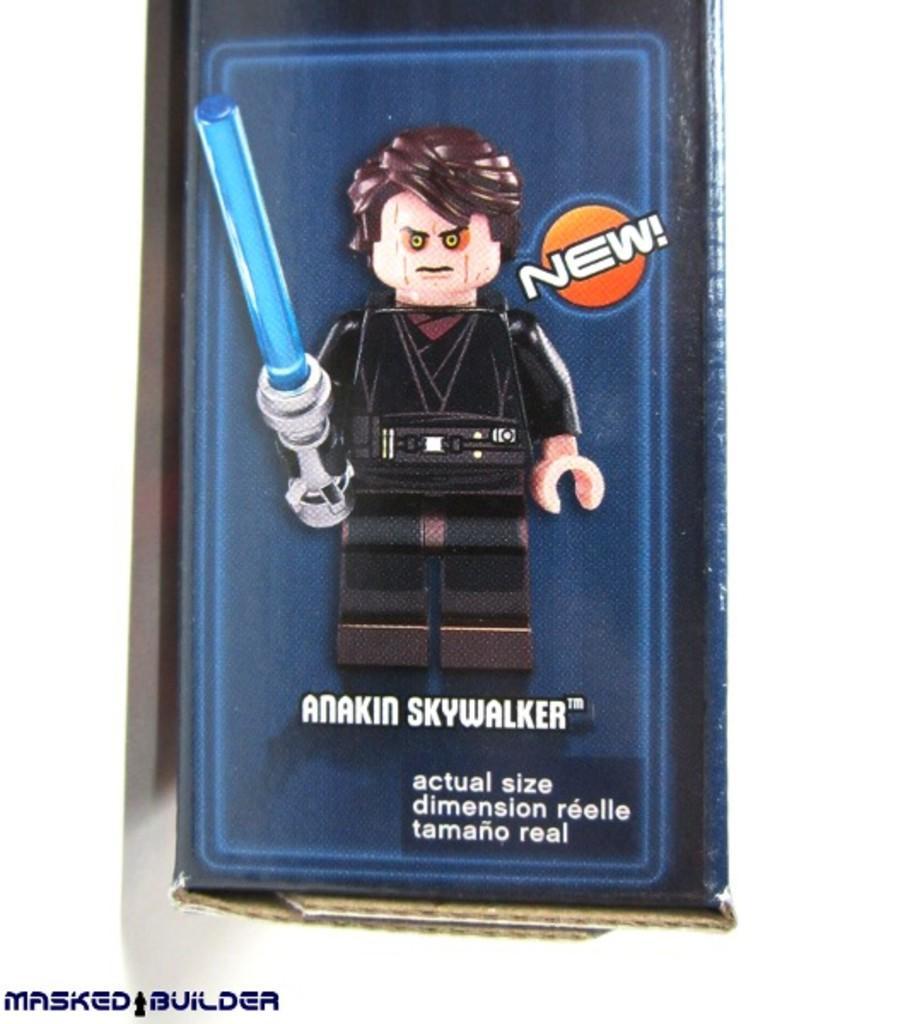Describe this image in one or two sentences. In this picture I can see a cartoon and some text and I can see a watermark at the bottom left corner of the picture. 